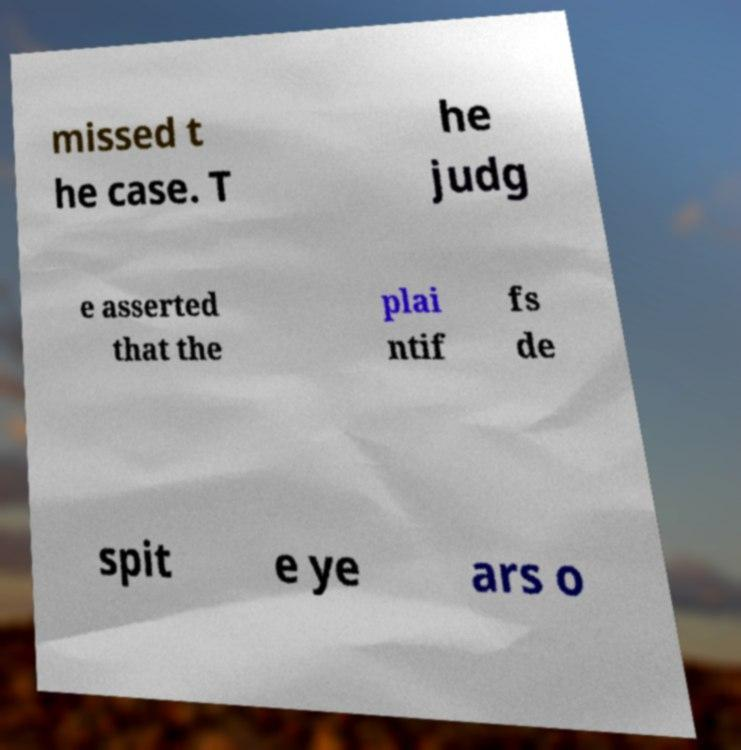What messages or text are displayed in this image? I need them in a readable, typed format. missed t he case. T he judg e asserted that the plai ntif fs de spit e ye ars o 